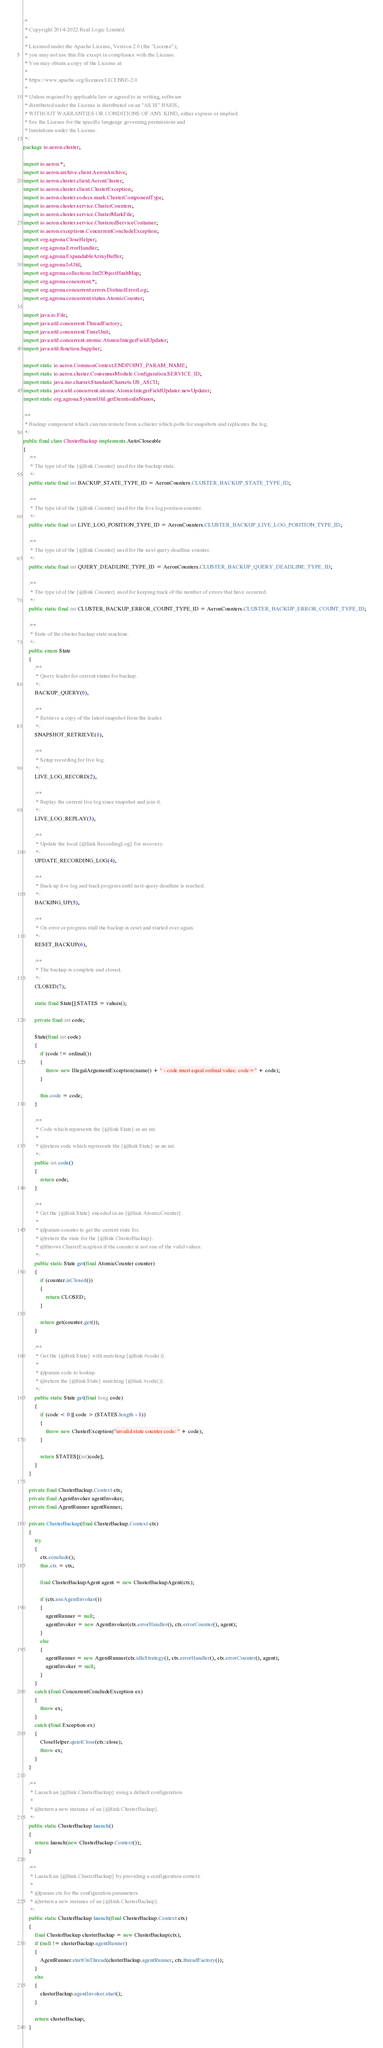<code> <loc_0><loc_0><loc_500><loc_500><_Java_>/*
 * Copyright 2014-2022 Real Logic Limited.
 *
 * Licensed under the Apache License, Version 2.0 (the "License");
 * you may not use this file except in compliance with the License.
 * You may obtain a copy of the License at
 *
 * https://www.apache.org/licenses/LICENSE-2.0
 *
 * Unless required by applicable law or agreed to in writing, software
 * distributed under the License is distributed on an "AS IS" BASIS,
 * WITHOUT WARRANTIES OR CONDITIONS OF ANY KIND, either express or implied.
 * See the License for the specific language governing permissions and
 * limitations under the License.
 */
package io.aeron.cluster;

import io.aeron.*;
import io.aeron.archive.client.AeronArchive;
import io.aeron.cluster.client.AeronCluster;
import io.aeron.cluster.client.ClusterException;
import io.aeron.cluster.codecs.mark.ClusterComponentType;
import io.aeron.cluster.service.ClusterCounters;
import io.aeron.cluster.service.ClusterMarkFile;
import io.aeron.cluster.service.ClusteredServiceContainer;
import io.aeron.exceptions.ConcurrentConcludeException;
import org.agrona.CloseHelper;
import org.agrona.ErrorHandler;
import org.agrona.ExpandableArrayBuffer;
import org.agrona.IoUtil;
import org.agrona.collections.Int2ObjectHashMap;
import org.agrona.concurrent.*;
import org.agrona.concurrent.errors.DistinctErrorLog;
import org.agrona.concurrent.status.AtomicCounter;

import java.io.File;
import java.util.concurrent.ThreadFactory;
import java.util.concurrent.TimeUnit;
import java.util.concurrent.atomic.AtomicIntegerFieldUpdater;
import java.util.function.Supplier;

import static io.aeron.CommonContext.ENDPOINT_PARAM_NAME;
import static io.aeron.cluster.ConsensusModule.Configuration.SERVICE_ID;
import static java.nio.charset.StandardCharsets.US_ASCII;
import static java.util.concurrent.atomic.AtomicIntegerFieldUpdater.newUpdater;
import static org.agrona.SystemUtil.getDurationInNanos;

/**
 * Backup component which can run remote from a cluster which polls for snapshots and replicates the log.
 */
public final class ClusterBackup implements AutoCloseable
{
    /**
     * The type id of the {@link Counter} used for the backup state.
     */
    public static final int BACKUP_STATE_TYPE_ID = AeronCounters.CLUSTER_BACKUP_STATE_TYPE_ID;

    /**
     * The type id of the {@link Counter} used for the live log position counter.
     */
    public static final int LIVE_LOG_POSITION_TYPE_ID = AeronCounters.CLUSTER_BACKUP_LIVE_LOG_POSITION_TYPE_ID;

    /**
     * The type id of the {@link Counter} used for the next query deadline counter.
     */
    public static final int QUERY_DEADLINE_TYPE_ID = AeronCounters.CLUSTER_BACKUP_QUERY_DEADLINE_TYPE_ID;

    /**
     * The type id of the {@link Counter} used for keeping track of the number of errors that have occurred.
     */
    public static final int CLUSTER_BACKUP_ERROR_COUNT_TYPE_ID = AeronCounters.CLUSTER_BACKUP_ERROR_COUNT_TYPE_ID;

    /**
     * State of the cluster backup state machine.
     */
    public enum State
    {
        /**
         * Query leader for current status for backup.
         */
        BACKUP_QUERY(0),

        /**
         * Retrieve a copy of the latest snapshot from the leader.
         */
        SNAPSHOT_RETRIEVE(1),

        /**
         * Setup recording for live log.
         */
        LIVE_LOG_RECORD(2),

        /**
         * Replay the current live log since snapshot and join it.
         */
        LIVE_LOG_REPLAY(3),

        /**
         * Update the local {@link RecordingLog} for recovery.
         */
        UPDATE_RECORDING_LOG(4),

        /**
         * Back up live log and track progress until next query deadline is reached.
         */
        BACKING_UP(5),

        /**
         * On error or progress stall the backup is reset and started over again.
         */
        RESET_BACKUP(6),

        /**
         * The backup is complete and closed.
         */
        CLOSED(7);

        static final State[] STATES = values();

        private final int code;

        State(final int code)
        {
            if (code != ordinal())
            {
                throw new IllegalArgumentException(name() + " - code must equal ordinal value: code=" + code);
            }

            this.code = code;
        }

        /**
         * Code which represents the {@link State} as an int.
         *
         * @return code which represents the {@link State} as an int.
         */
        public int code()
        {
            return code;
        }

        /**
         * Get the {@link State} encoded in an {@link AtomicCounter}.
         *
         * @param counter to get the current state for.
         * @return the state for the {@link ClusterBackup}.
         * @throws ClusterException if the counter is not one of the valid values.
         */
        public static State get(final AtomicCounter counter)
        {
            if (counter.isClosed())
            {
                return CLOSED;
            }

            return get(counter.get());
        }

        /**
         * Get the {@link State} with matching {@link #code()}.
         *
         * @param code to lookup.
         * @return the {@link State} matching {@link #code()}.
         */
        public static State get(final long code)
        {
            if (code < 0 || code > (STATES.length - 1))
            {
                throw new ClusterException("invalid state counter code: " + code);
            }

            return STATES[(int)code];
        }
    }

    private final ClusterBackup.Context ctx;
    private final AgentInvoker agentInvoker;
    private final AgentRunner agentRunner;

    private ClusterBackup(final ClusterBackup.Context ctx)
    {
        try
        {
            ctx.conclude();
            this.ctx = ctx;

            final ClusterBackupAgent agent = new ClusterBackupAgent(ctx);

            if (ctx.useAgentInvoker())
            {
                agentRunner = null;
                agentInvoker = new AgentInvoker(ctx.errorHandler(), ctx.errorCounter(), agent);
            }
            else
            {
                agentRunner = new AgentRunner(ctx.idleStrategy(), ctx.errorHandler(), ctx.errorCounter(), agent);
                agentInvoker = null;
            }
        }
        catch (final ConcurrentConcludeException ex)
        {
            throw ex;
        }
        catch (final Exception ex)
        {
            CloseHelper.quietClose(ctx::close);
            throw ex;
        }
    }

    /**
     * Launch an {@link ClusterBackup} using a default configuration.
     *
     * @return a new instance of an {@link ClusterBackup}.
     */
    public static ClusterBackup launch()
    {
        return launch(new ClusterBackup.Context());
    }

    /**
     * Launch an {@link ClusterBackup} by providing a configuration context.
     *
     * @param ctx for the configuration parameters.
     * @return a new instance of an {@link ClusterBackup}.
     */
    public static ClusterBackup launch(final ClusterBackup.Context ctx)
    {
        final ClusterBackup clusterBackup = new ClusterBackup(ctx);
        if (null != clusterBackup.agentRunner)
        {
            AgentRunner.startOnThread(clusterBackup.agentRunner, ctx.threadFactory());
        }
        else
        {
            clusterBackup.agentInvoker.start();
        }

        return clusterBackup;
    }
</code> 